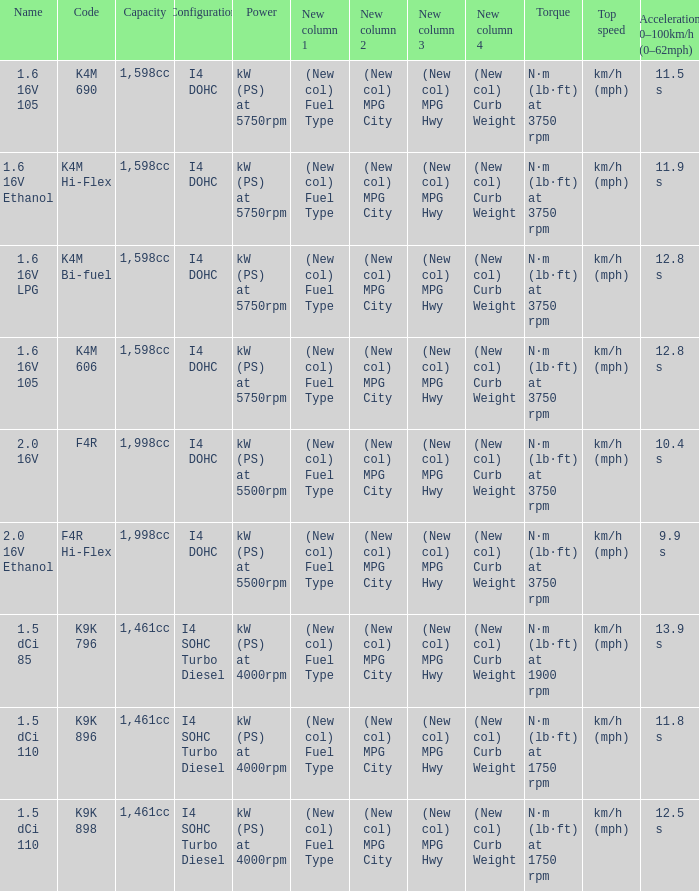What is the capacity of code f4r? 1,998cc. Would you mind parsing the complete table? {'header': ['Name', 'Code', 'Capacity', 'Configuration', 'Power', 'New column 1', 'New column 2', 'New column 3', 'New column 4', 'Torque', 'Top speed', 'Acceleration 0–100km/h (0–62mph)'], 'rows': [['1.6 16V 105', 'K4M 690', '1,598cc', 'I4 DOHC', 'kW (PS) at 5750rpm', '(New col) Fuel Type', '(New col) MPG City', '(New col) MPG Hwy', '(New col) Curb Weight', 'N·m (lb·ft) at 3750 rpm', 'km/h (mph)', '11.5 s'], ['1.6 16V Ethanol', 'K4M Hi-Flex', '1,598cc', 'I4 DOHC', 'kW (PS) at 5750rpm', '(New col) Fuel Type', '(New col) MPG City', '(New col) MPG Hwy', '(New col) Curb Weight', 'N·m (lb·ft) at 3750 rpm', 'km/h (mph)', '11.9 s'], ['1.6 16V LPG', 'K4M Bi-fuel', '1,598cc', 'I4 DOHC', 'kW (PS) at 5750rpm', '(New col) Fuel Type', '(New col) MPG City', '(New col) MPG Hwy', '(New col) Curb Weight', 'N·m (lb·ft) at 3750 rpm', 'km/h (mph)', '12.8 s'], ['1.6 16V 105', 'K4M 606', '1,598cc', 'I4 DOHC', 'kW (PS) at 5750rpm', '(New col) Fuel Type', '(New col) MPG City', '(New col) MPG Hwy', '(New col) Curb Weight', 'N·m (lb·ft) at 3750 rpm', 'km/h (mph)', '12.8 s'], ['2.0 16V', 'F4R', '1,998cc', 'I4 DOHC', 'kW (PS) at 5500rpm', '(New col) Fuel Type', '(New col) MPG City', '(New col) MPG Hwy', '(New col) Curb Weight', 'N·m (lb·ft) at 3750 rpm', 'km/h (mph)', '10.4 s'], ['2.0 16V Ethanol', 'F4R Hi-Flex', '1,998cc', 'I4 DOHC', 'kW (PS) at 5500rpm', '(New col) Fuel Type', '(New col) MPG City', '(New col) MPG Hwy', '(New col) Curb Weight', 'N·m (lb·ft) at 3750 rpm', 'km/h (mph)', '9.9 s'], ['1.5 dCi 85', 'K9K 796', '1,461cc', 'I4 SOHC Turbo Diesel', 'kW (PS) at 4000rpm', '(New col) Fuel Type', '(New col) MPG City', '(New col) MPG Hwy', '(New col) Curb Weight', 'N·m (lb·ft) at 1900 rpm', 'km/h (mph)', '13.9 s'], ['1.5 dCi 110', 'K9K 896', '1,461cc', 'I4 SOHC Turbo Diesel', 'kW (PS) at 4000rpm', '(New col) Fuel Type', '(New col) MPG City', '(New col) MPG Hwy', '(New col) Curb Weight', 'N·m (lb·ft) at 1750 rpm', 'km/h (mph)', '11.8 s'], ['1.5 dCi 110', 'K9K 898', '1,461cc', 'I4 SOHC Turbo Diesel', 'kW (PS) at 4000rpm', '(New col) Fuel Type', '(New col) MPG City', '(New col) MPG Hwy', '(New col) Curb Weight', 'N·m (lb·ft) at 1750 rpm', 'km/h (mph)', '12.5 s']]} 